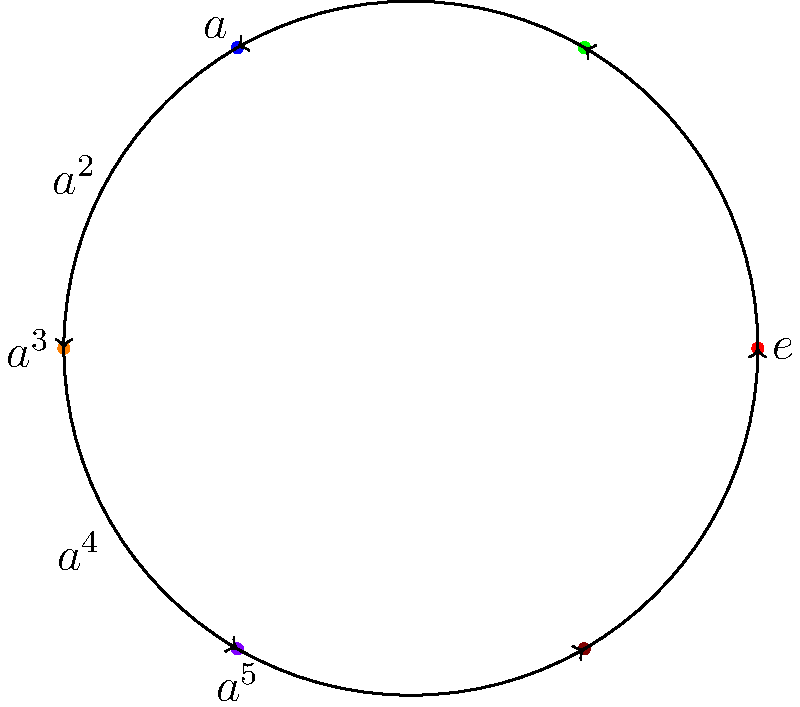In the context of Nigerian tribal dance formations, consider the cyclic group $C_6$ represented by the diagram. If each colored dot represents a dancer's position and the arrows indicate the clockwise rotation to the next position, how many rotations are needed for a dancer starting at position $a^2$ to return to their original position? To solve this problem, we need to understand the properties of cyclic groups and how they relate to the dance formation:

1. The diagram represents a cyclic group $C_6$ with 6 elements: $e, a, a^2, a^3, a^4, a^5$.
2. Each element represents a dancer's position in the formation.
3. The arrows indicate a clockwise rotation, which is the group operation.
4. In a cyclic group, repeated application of the group operation eventually returns to the identity element (starting position).

Let's follow the rotations starting from $a^2$:
1. $a^2 \rightarrow a^3$ (1st rotation)
2. $a^3 \rightarrow a^4$ (2nd rotation)
3. $a^4 \rightarrow a^5$ (3rd rotation)
4. $a^5 \rightarrow e$ (4th rotation)
5. $e \rightarrow a$ (5th rotation)
6. $a \rightarrow a^2$ (6th rotation)

After 6 rotations, the dancer returns to the original position $a^2$. This is consistent with the order of the cyclic group $C_6$, which is 6.

In group theory terms, we can express this as $(a^2)^6 = e$, where $e$ is the identity element.
Answer: 6 rotations 